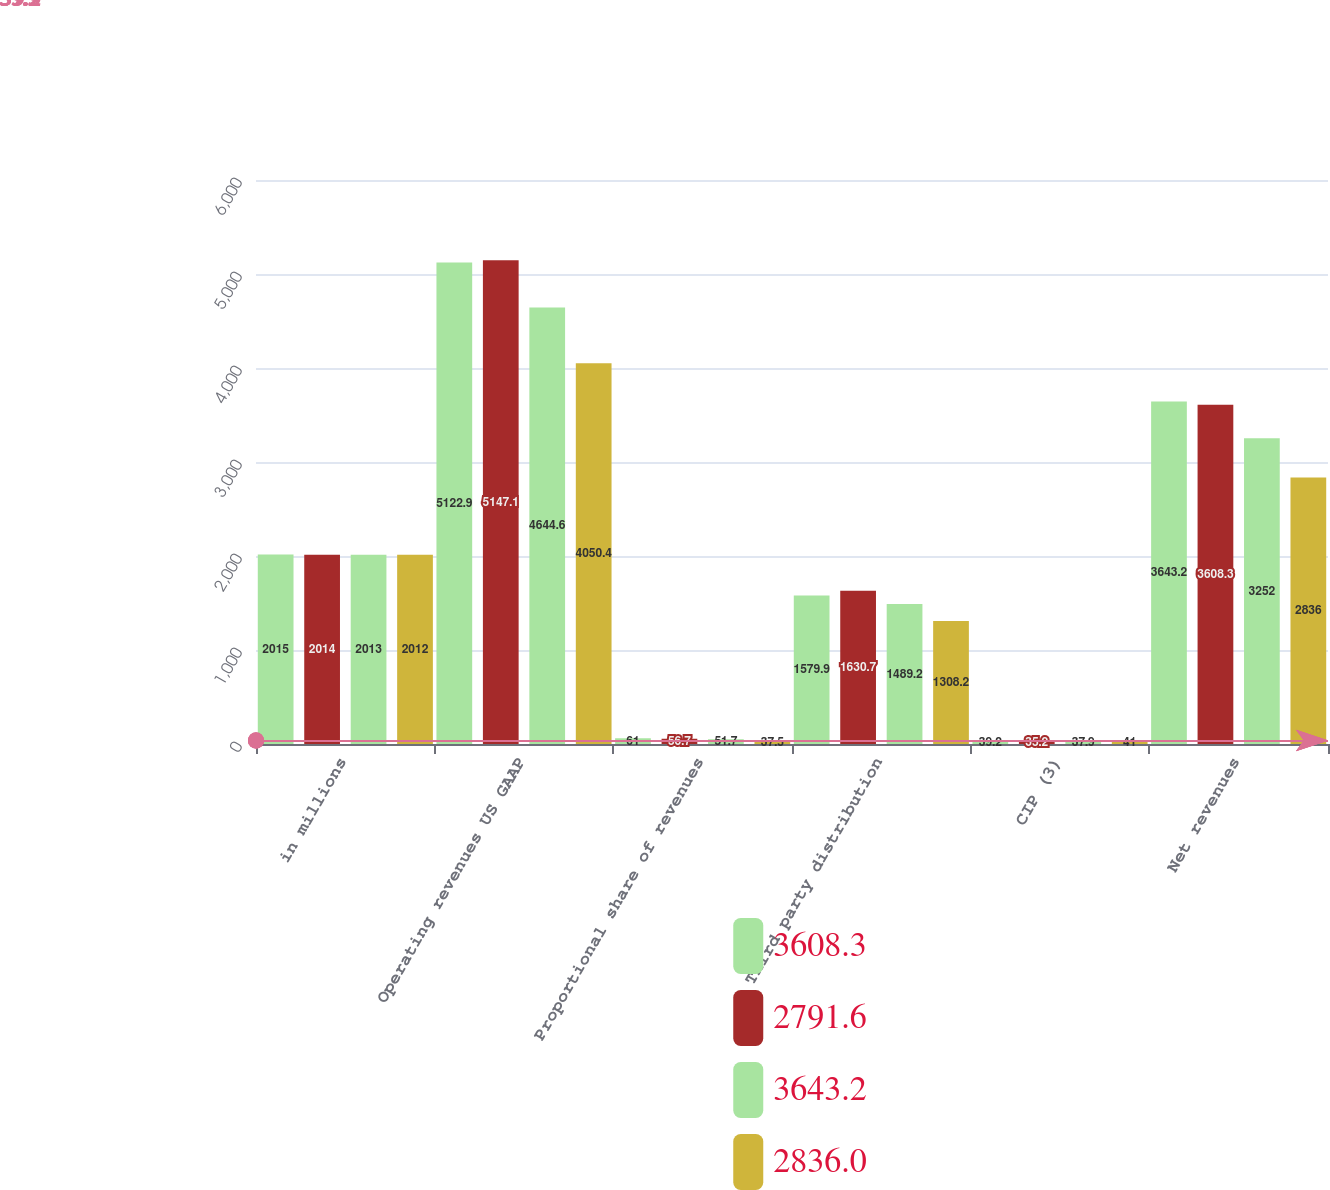Convert chart. <chart><loc_0><loc_0><loc_500><loc_500><stacked_bar_chart><ecel><fcel>in millions<fcel>Operating revenues US GAAP<fcel>Proportional share of revenues<fcel>Third party distribution<fcel>CIP (3)<fcel>Net revenues<nl><fcel>3608.3<fcel>2015<fcel>5122.9<fcel>61<fcel>1579.9<fcel>39.2<fcel>3643.2<nl><fcel>2791.6<fcel>2014<fcel>5147.1<fcel>56.7<fcel>1630.7<fcel>35.2<fcel>3608.3<nl><fcel>3643.2<fcel>2013<fcel>4644.6<fcel>51.7<fcel>1489.2<fcel>37.9<fcel>3252<nl><fcel>2836<fcel>2012<fcel>4050.4<fcel>37.5<fcel>1308.2<fcel>41<fcel>2836<nl></chart> 